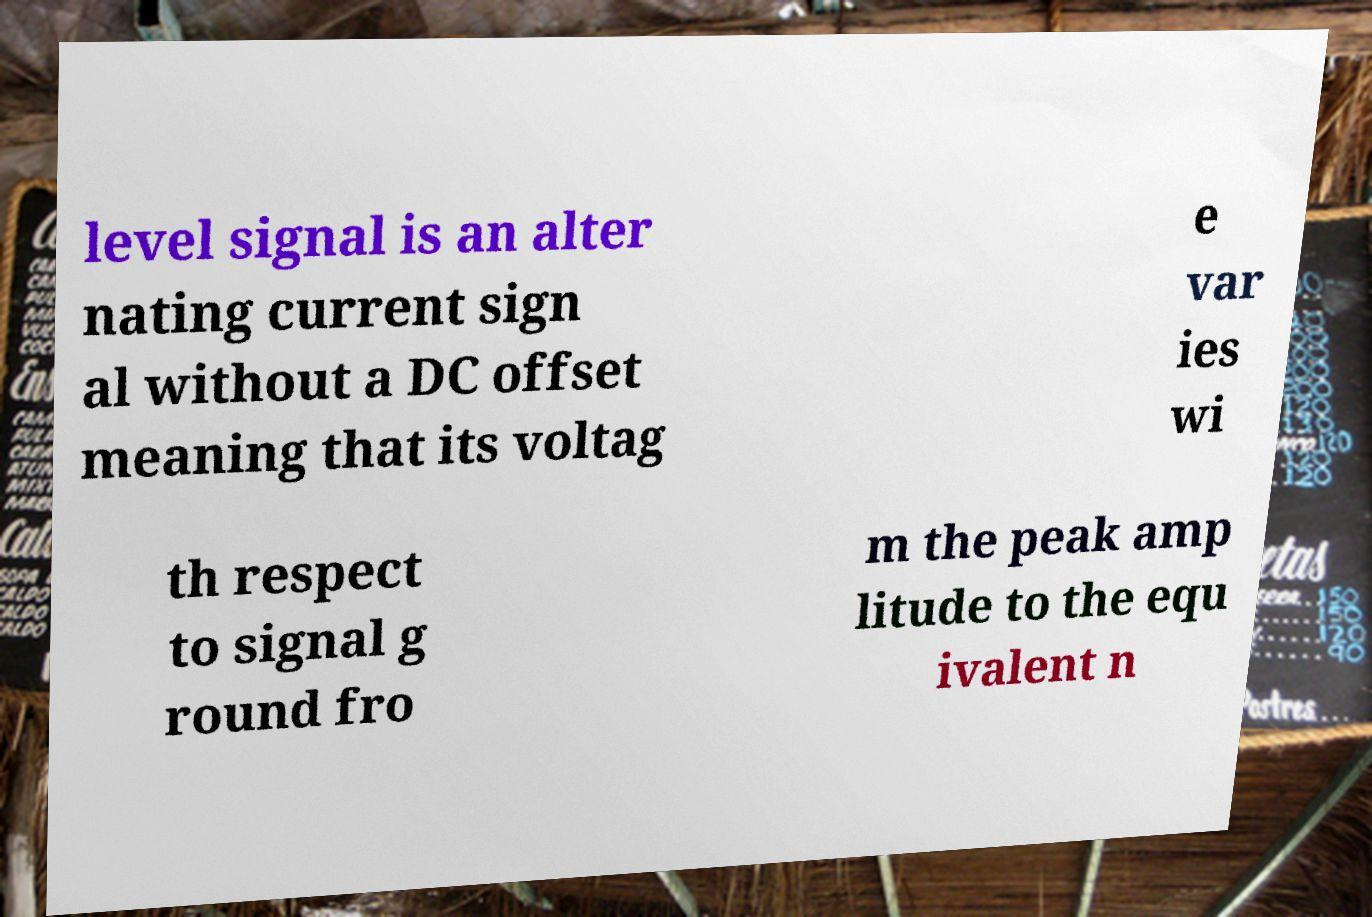Please read and relay the text visible in this image. What does it say? level signal is an alter nating current sign al without a DC offset meaning that its voltag e var ies wi th respect to signal g round fro m the peak amp litude to the equ ivalent n 